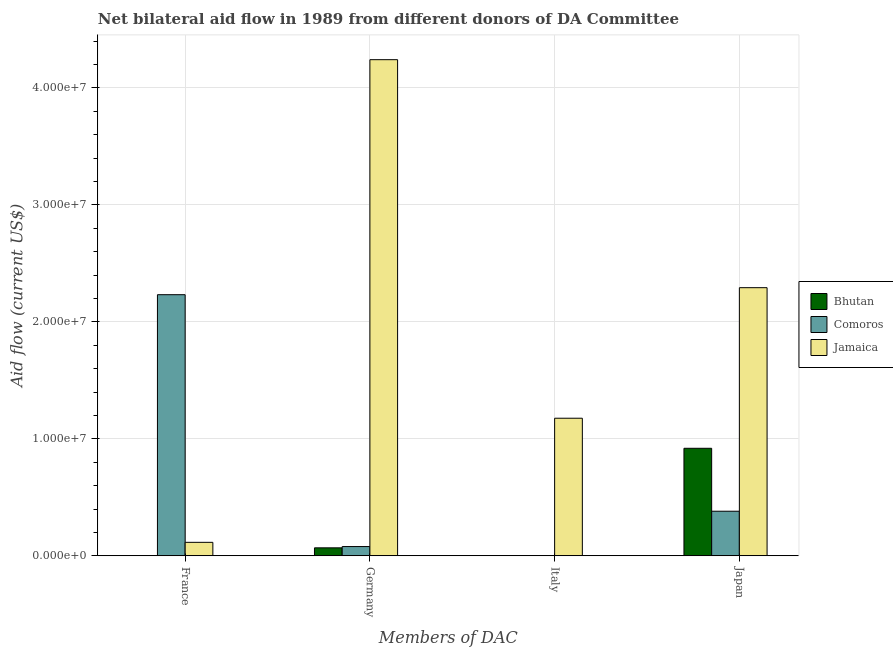How many different coloured bars are there?
Provide a short and direct response. 3. How many groups of bars are there?
Offer a terse response. 4. Are the number of bars per tick equal to the number of legend labels?
Provide a short and direct response. No. What is the amount of aid given by italy in Comoros?
Your answer should be compact. 2.00e+04. Across all countries, what is the maximum amount of aid given by germany?
Provide a succinct answer. 4.24e+07. Across all countries, what is the minimum amount of aid given by germany?
Offer a very short reply. 6.80e+05. In which country was the amount of aid given by japan maximum?
Make the answer very short. Jamaica. What is the total amount of aid given by italy in the graph?
Provide a short and direct response. 1.18e+07. What is the difference between the amount of aid given by japan in Bhutan and that in Jamaica?
Your answer should be very brief. -1.37e+07. What is the difference between the amount of aid given by japan in Bhutan and the amount of aid given by italy in Comoros?
Give a very brief answer. 9.17e+06. What is the average amount of aid given by italy per country?
Ensure brevity in your answer.  3.93e+06. What is the difference between the amount of aid given by germany and amount of aid given by france in Jamaica?
Offer a terse response. 4.13e+07. In how many countries, is the amount of aid given by germany greater than 12000000 US$?
Provide a succinct answer. 1. What is the ratio of the amount of aid given by france in Bhutan to that in Comoros?
Your response must be concise. 0. What is the difference between the highest and the second highest amount of aid given by france?
Ensure brevity in your answer.  2.12e+07. What is the difference between the highest and the lowest amount of aid given by japan?
Keep it short and to the point. 1.91e+07. Is the sum of the amount of aid given by france in Bhutan and Jamaica greater than the maximum amount of aid given by japan across all countries?
Offer a very short reply. No. Is it the case that in every country, the sum of the amount of aid given by germany and amount of aid given by france is greater than the sum of amount of aid given by japan and amount of aid given by italy?
Keep it short and to the point. No. Is it the case that in every country, the sum of the amount of aid given by france and amount of aid given by germany is greater than the amount of aid given by italy?
Make the answer very short. Yes. How many bars are there?
Give a very brief answer. 11. What is the difference between two consecutive major ticks on the Y-axis?
Make the answer very short. 1.00e+07. Does the graph contain any zero values?
Provide a succinct answer. Yes. Does the graph contain grids?
Ensure brevity in your answer.  Yes. What is the title of the graph?
Provide a short and direct response. Net bilateral aid flow in 1989 from different donors of DA Committee. Does "Iran" appear as one of the legend labels in the graph?
Your answer should be compact. No. What is the label or title of the X-axis?
Provide a short and direct response. Members of DAC. What is the Aid flow (current US$) in Comoros in France?
Your answer should be compact. 2.23e+07. What is the Aid flow (current US$) in Jamaica in France?
Make the answer very short. 1.15e+06. What is the Aid flow (current US$) of Bhutan in Germany?
Offer a terse response. 6.80e+05. What is the Aid flow (current US$) of Comoros in Germany?
Provide a succinct answer. 7.90e+05. What is the Aid flow (current US$) of Jamaica in Germany?
Provide a short and direct response. 4.24e+07. What is the Aid flow (current US$) in Bhutan in Italy?
Provide a short and direct response. 0. What is the Aid flow (current US$) in Comoros in Italy?
Offer a terse response. 2.00e+04. What is the Aid flow (current US$) in Jamaica in Italy?
Provide a short and direct response. 1.18e+07. What is the Aid flow (current US$) in Bhutan in Japan?
Provide a short and direct response. 9.19e+06. What is the Aid flow (current US$) of Comoros in Japan?
Your response must be concise. 3.81e+06. What is the Aid flow (current US$) in Jamaica in Japan?
Your answer should be compact. 2.29e+07. Across all Members of DAC, what is the maximum Aid flow (current US$) in Bhutan?
Your answer should be very brief. 9.19e+06. Across all Members of DAC, what is the maximum Aid flow (current US$) of Comoros?
Provide a short and direct response. 2.23e+07. Across all Members of DAC, what is the maximum Aid flow (current US$) in Jamaica?
Make the answer very short. 4.24e+07. Across all Members of DAC, what is the minimum Aid flow (current US$) of Bhutan?
Ensure brevity in your answer.  0. Across all Members of DAC, what is the minimum Aid flow (current US$) of Jamaica?
Offer a very short reply. 1.15e+06. What is the total Aid flow (current US$) of Bhutan in the graph?
Ensure brevity in your answer.  9.88e+06. What is the total Aid flow (current US$) of Comoros in the graph?
Your answer should be compact. 2.69e+07. What is the total Aid flow (current US$) in Jamaica in the graph?
Offer a terse response. 7.82e+07. What is the difference between the Aid flow (current US$) of Bhutan in France and that in Germany?
Your answer should be compact. -6.70e+05. What is the difference between the Aid flow (current US$) in Comoros in France and that in Germany?
Keep it short and to the point. 2.15e+07. What is the difference between the Aid flow (current US$) in Jamaica in France and that in Germany?
Make the answer very short. -4.13e+07. What is the difference between the Aid flow (current US$) in Comoros in France and that in Italy?
Keep it short and to the point. 2.23e+07. What is the difference between the Aid flow (current US$) in Jamaica in France and that in Italy?
Offer a very short reply. -1.06e+07. What is the difference between the Aid flow (current US$) of Bhutan in France and that in Japan?
Provide a succinct answer. -9.18e+06. What is the difference between the Aid flow (current US$) of Comoros in France and that in Japan?
Provide a succinct answer. 1.85e+07. What is the difference between the Aid flow (current US$) of Jamaica in France and that in Japan?
Your response must be concise. -2.18e+07. What is the difference between the Aid flow (current US$) of Comoros in Germany and that in Italy?
Make the answer very short. 7.70e+05. What is the difference between the Aid flow (current US$) of Jamaica in Germany and that in Italy?
Ensure brevity in your answer.  3.06e+07. What is the difference between the Aid flow (current US$) in Bhutan in Germany and that in Japan?
Provide a short and direct response. -8.51e+06. What is the difference between the Aid flow (current US$) of Comoros in Germany and that in Japan?
Offer a very short reply. -3.02e+06. What is the difference between the Aid flow (current US$) of Jamaica in Germany and that in Japan?
Ensure brevity in your answer.  1.95e+07. What is the difference between the Aid flow (current US$) in Comoros in Italy and that in Japan?
Provide a short and direct response. -3.79e+06. What is the difference between the Aid flow (current US$) in Jamaica in Italy and that in Japan?
Offer a very short reply. -1.12e+07. What is the difference between the Aid flow (current US$) in Bhutan in France and the Aid flow (current US$) in Comoros in Germany?
Ensure brevity in your answer.  -7.80e+05. What is the difference between the Aid flow (current US$) in Bhutan in France and the Aid flow (current US$) in Jamaica in Germany?
Make the answer very short. -4.24e+07. What is the difference between the Aid flow (current US$) of Comoros in France and the Aid flow (current US$) of Jamaica in Germany?
Make the answer very short. -2.01e+07. What is the difference between the Aid flow (current US$) of Bhutan in France and the Aid flow (current US$) of Comoros in Italy?
Provide a short and direct response. -10000. What is the difference between the Aid flow (current US$) of Bhutan in France and the Aid flow (current US$) of Jamaica in Italy?
Offer a terse response. -1.18e+07. What is the difference between the Aid flow (current US$) in Comoros in France and the Aid flow (current US$) in Jamaica in Italy?
Offer a very short reply. 1.06e+07. What is the difference between the Aid flow (current US$) of Bhutan in France and the Aid flow (current US$) of Comoros in Japan?
Your answer should be compact. -3.80e+06. What is the difference between the Aid flow (current US$) of Bhutan in France and the Aid flow (current US$) of Jamaica in Japan?
Make the answer very short. -2.29e+07. What is the difference between the Aid flow (current US$) of Comoros in France and the Aid flow (current US$) of Jamaica in Japan?
Your answer should be very brief. -6.00e+05. What is the difference between the Aid flow (current US$) of Bhutan in Germany and the Aid flow (current US$) of Jamaica in Italy?
Provide a short and direct response. -1.11e+07. What is the difference between the Aid flow (current US$) of Comoros in Germany and the Aid flow (current US$) of Jamaica in Italy?
Make the answer very short. -1.10e+07. What is the difference between the Aid flow (current US$) in Bhutan in Germany and the Aid flow (current US$) in Comoros in Japan?
Keep it short and to the point. -3.13e+06. What is the difference between the Aid flow (current US$) of Bhutan in Germany and the Aid flow (current US$) of Jamaica in Japan?
Your response must be concise. -2.22e+07. What is the difference between the Aid flow (current US$) in Comoros in Germany and the Aid flow (current US$) in Jamaica in Japan?
Keep it short and to the point. -2.21e+07. What is the difference between the Aid flow (current US$) of Comoros in Italy and the Aid flow (current US$) of Jamaica in Japan?
Your response must be concise. -2.29e+07. What is the average Aid flow (current US$) of Bhutan per Members of DAC?
Your response must be concise. 2.47e+06. What is the average Aid flow (current US$) of Comoros per Members of DAC?
Ensure brevity in your answer.  6.74e+06. What is the average Aid flow (current US$) in Jamaica per Members of DAC?
Give a very brief answer. 1.96e+07. What is the difference between the Aid flow (current US$) in Bhutan and Aid flow (current US$) in Comoros in France?
Offer a very short reply. -2.23e+07. What is the difference between the Aid flow (current US$) in Bhutan and Aid flow (current US$) in Jamaica in France?
Provide a short and direct response. -1.14e+06. What is the difference between the Aid flow (current US$) in Comoros and Aid flow (current US$) in Jamaica in France?
Ensure brevity in your answer.  2.12e+07. What is the difference between the Aid flow (current US$) of Bhutan and Aid flow (current US$) of Jamaica in Germany?
Provide a short and direct response. -4.17e+07. What is the difference between the Aid flow (current US$) of Comoros and Aid flow (current US$) of Jamaica in Germany?
Your answer should be very brief. -4.16e+07. What is the difference between the Aid flow (current US$) of Comoros and Aid flow (current US$) of Jamaica in Italy?
Ensure brevity in your answer.  -1.17e+07. What is the difference between the Aid flow (current US$) in Bhutan and Aid flow (current US$) in Comoros in Japan?
Your answer should be very brief. 5.38e+06. What is the difference between the Aid flow (current US$) of Bhutan and Aid flow (current US$) of Jamaica in Japan?
Your answer should be compact. -1.37e+07. What is the difference between the Aid flow (current US$) in Comoros and Aid flow (current US$) in Jamaica in Japan?
Offer a terse response. -1.91e+07. What is the ratio of the Aid flow (current US$) of Bhutan in France to that in Germany?
Give a very brief answer. 0.01. What is the ratio of the Aid flow (current US$) of Comoros in France to that in Germany?
Offer a terse response. 28.25. What is the ratio of the Aid flow (current US$) of Jamaica in France to that in Germany?
Offer a very short reply. 0.03. What is the ratio of the Aid flow (current US$) of Comoros in France to that in Italy?
Ensure brevity in your answer.  1116. What is the ratio of the Aid flow (current US$) in Jamaica in France to that in Italy?
Your answer should be very brief. 0.1. What is the ratio of the Aid flow (current US$) of Bhutan in France to that in Japan?
Keep it short and to the point. 0. What is the ratio of the Aid flow (current US$) in Comoros in France to that in Japan?
Your answer should be very brief. 5.86. What is the ratio of the Aid flow (current US$) of Jamaica in France to that in Japan?
Ensure brevity in your answer.  0.05. What is the ratio of the Aid flow (current US$) in Comoros in Germany to that in Italy?
Offer a terse response. 39.5. What is the ratio of the Aid flow (current US$) in Jamaica in Germany to that in Italy?
Offer a very short reply. 3.61. What is the ratio of the Aid flow (current US$) in Bhutan in Germany to that in Japan?
Your answer should be very brief. 0.07. What is the ratio of the Aid flow (current US$) in Comoros in Germany to that in Japan?
Make the answer very short. 0.21. What is the ratio of the Aid flow (current US$) of Jamaica in Germany to that in Japan?
Your answer should be compact. 1.85. What is the ratio of the Aid flow (current US$) in Comoros in Italy to that in Japan?
Offer a terse response. 0.01. What is the ratio of the Aid flow (current US$) of Jamaica in Italy to that in Japan?
Give a very brief answer. 0.51. What is the difference between the highest and the second highest Aid flow (current US$) of Bhutan?
Your answer should be very brief. 8.51e+06. What is the difference between the highest and the second highest Aid flow (current US$) in Comoros?
Provide a succinct answer. 1.85e+07. What is the difference between the highest and the second highest Aid flow (current US$) in Jamaica?
Keep it short and to the point. 1.95e+07. What is the difference between the highest and the lowest Aid flow (current US$) of Bhutan?
Make the answer very short. 9.19e+06. What is the difference between the highest and the lowest Aid flow (current US$) of Comoros?
Provide a succinct answer. 2.23e+07. What is the difference between the highest and the lowest Aid flow (current US$) in Jamaica?
Keep it short and to the point. 4.13e+07. 